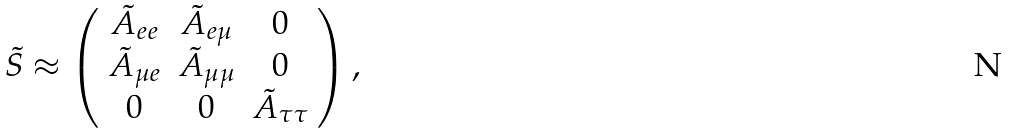Convert formula to latex. <formula><loc_0><loc_0><loc_500><loc_500>\tilde { S } \approx \left ( \begin{array} { c c c } \tilde { A } _ { e e } & \tilde { A } _ { e \mu } & 0 \\ \tilde { A } _ { \mu e } & \tilde { A } _ { \mu \mu } & 0 \\ 0 & 0 & \tilde { A } _ { \tau \tau } \end{array} \right ) ,</formula> 